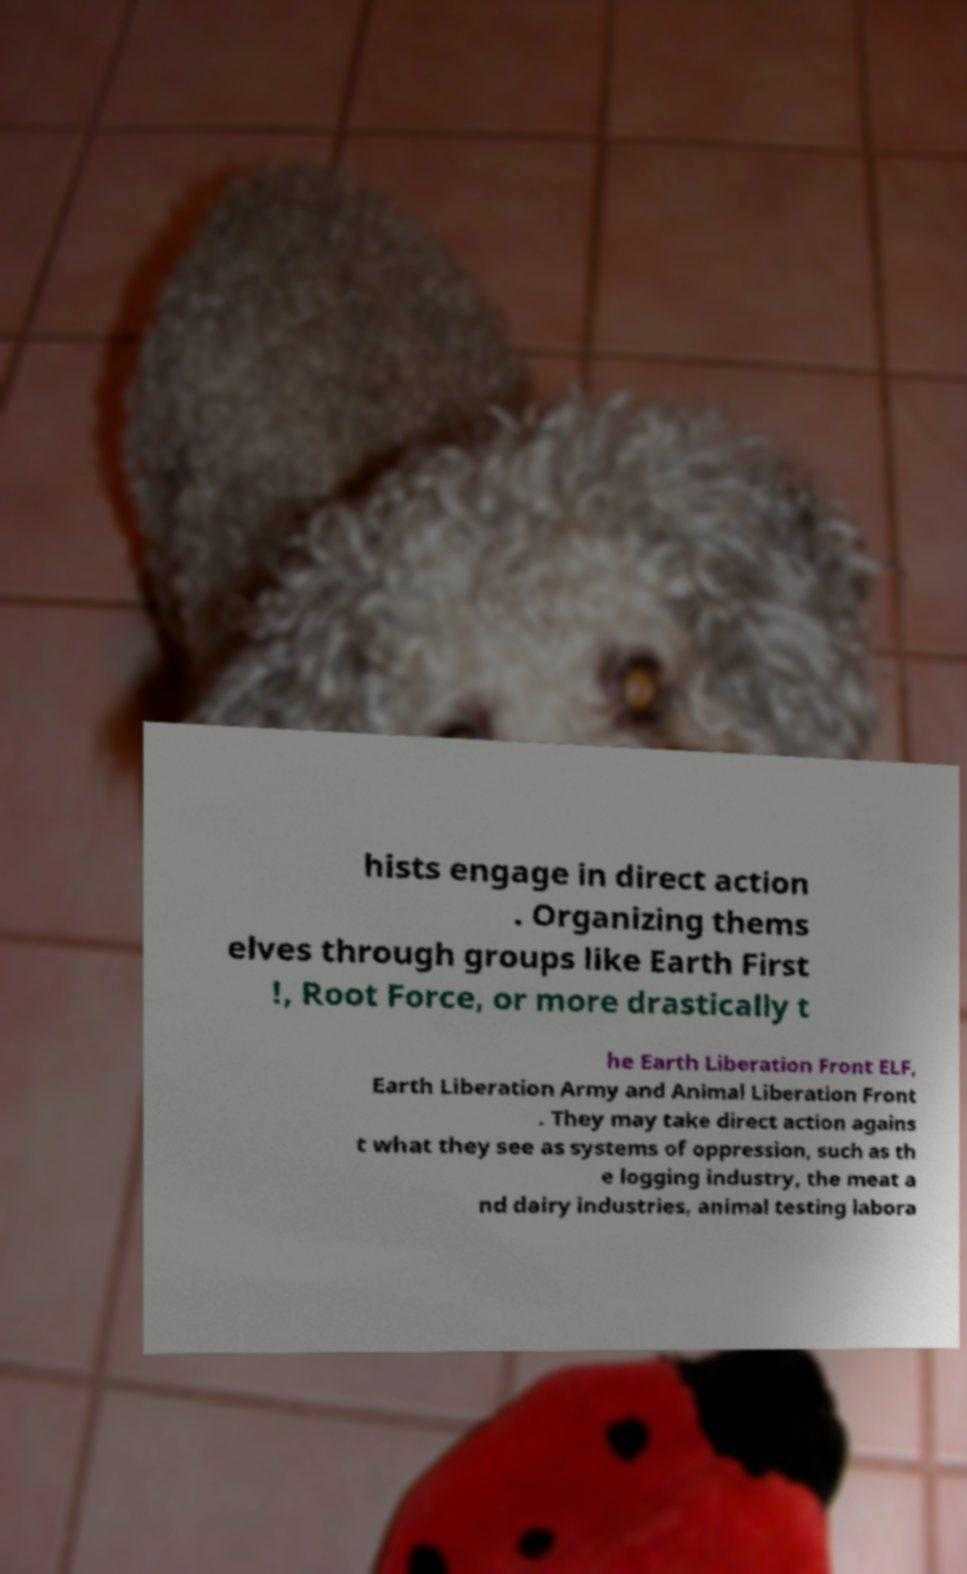For documentation purposes, I need the text within this image transcribed. Could you provide that? hists engage in direct action . Organizing thems elves through groups like Earth First !, Root Force, or more drastically t he Earth Liberation Front ELF, Earth Liberation Army and Animal Liberation Front . They may take direct action agains t what they see as systems of oppression, such as th e logging industry, the meat a nd dairy industries, animal testing labora 